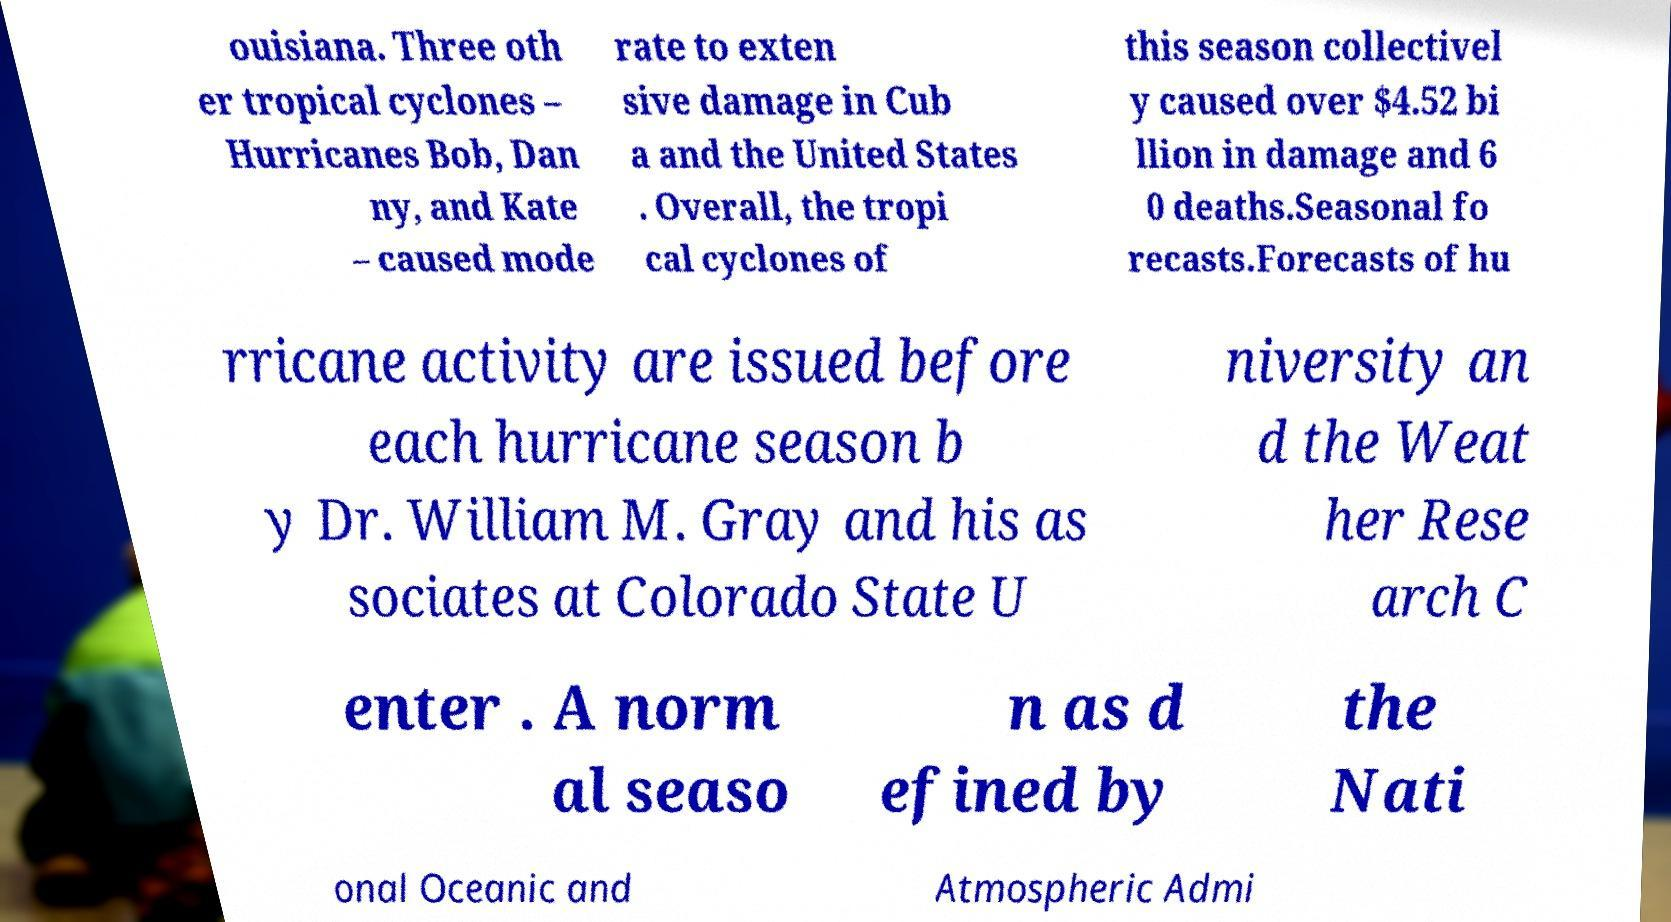Could you extract and type out the text from this image? ouisiana. Three oth er tropical cyclones – Hurricanes Bob, Dan ny, and Kate – caused mode rate to exten sive damage in Cub a and the United States . Overall, the tropi cal cyclones of this season collectivel y caused over $4.52 bi llion in damage and 6 0 deaths.Seasonal fo recasts.Forecasts of hu rricane activity are issued before each hurricane season b y Dr. William M. Gray and his as sociates at Colorado State U niversity an d the Weat her Rese arch C enter . A norm al seaso n as d efined by the Nati onal Oceanic and Atmospheric Admi 